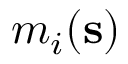Convert formula to latex. <formula><loc_0><loc_0><loc_500><loc_500>m _ { i } ( s )</formula> 